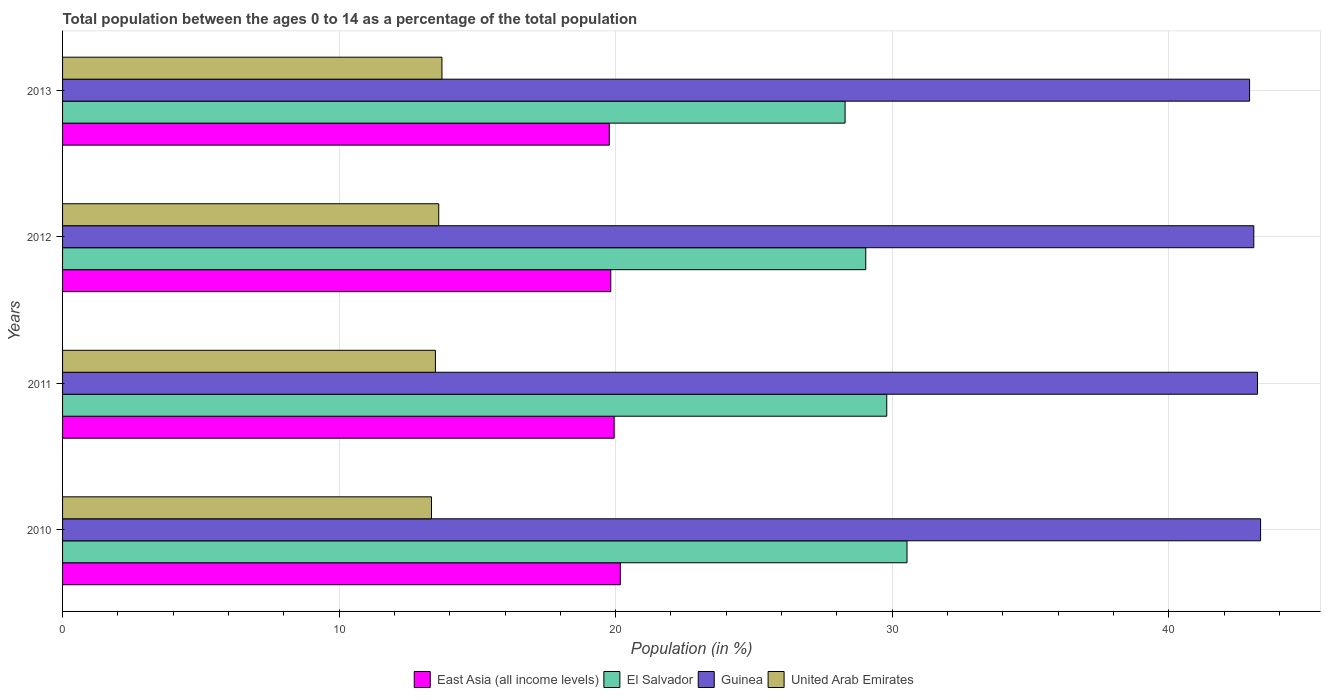Are the number of bars on each tick of the Y-axis equal?
Offer a terse response. Yes. What is the label of the 2nd group of bars from the top?
Give a very brief answer. 2012. In how many cases, is the number of bars for a given year not equal to the number of legend labels?
Offer a very short reply. 0. What is the percentage of the population ages 0 to 14 in El Salvador in 2011?
Offer a very short reply. 29.8. Across all years, what is the maximum percentage of the population ages 0 to 14 in United Arab Emirates?
Make the answer very short. 13.72. Across all years, what is the minimum percentage of the population ages 0 to 14 in El Salvador?
Provide a succinct answer. 28.3. In which year was the percentage of the population ages 0 to 14 in East Asia (all income levels) maximum?
Give a very brief answer. 2010. In which year was the percentage of the population ages 0 to 14 in East Asia (all income levels) minimum?
Your answer should be compact. 2013. What is the total percentage of the population ages 0 to 14 in East Asia (all income levels) in the graph?
Provide a short and direct response. 79.7. What is the difference between the percentage of the population ages 0 to 14 in East Asia (all income levels) in 2010 and that in 2011?
Keep it short and to the point. 0.22. What is the difference between the percentage of the population ages 0 to 14 in United Arab Emirates in 2010 and the percentage of the population ages 0 to 14 in Guinea in 2013?
Make the answer very short. -29.58. What is the average percentage of the population ages 0 to 14 in El Salvador per year?
Keep it short and to the point. 29.42. In the year 2010, what is the difference between the percentage of the population ages 0 to 14 in United Arab Emirates and percentage of the population ages 0 to 14 in East Asia (all income levels)?
Offer a terse response. -6.83. In how many years, is the percentage of the population ages 0 to 14 in United Arab Emirates greater than 36 ?
Offer a terse response. 0. What is the ratio of the percentage of the population ages 0 to 14 in Guinea in 2010 to that in 2011?
Give a very brief answer. 1. Is the difference between the percentage of the population ages 0 to 14 in United Arab Emirates in 2012 and 2013 greater than the difference between the percentage of the population ages 0 to 14 in East Asia (all income levels) in 2012 and 2013?
Provide a succinct answer. No. What is the difference between the highest and the second highest percentage of the population ages 0 to 14 in Guinea?
Your answer should be compact. 0.11. What is the difference between the highest and the lowest percentage of the population ages 0 to 14 in East Asia (all income levels)?
Your answer should be compact. 0.4. In how many years, is the percentage of the population ages 0 to 14 in East Asia (all income levels) greater than the average percentage of the population ages 0 to 14 in East Asia (all income levels) taken over all years?
Your answer should be very brief. 2. What does the 4th bar from the top in 2013 represents?
Offer a very short reply. East Asia (all income levels). What does the 3rd bar from the bottom in 2013 represents?
Ensure brevity in your answer.  Guinea. How many years are there in the graph?
Provide a short and direct response. 4. Are the values on the major ticks of X-axis written in scientific E-notation?
Offer a very short reply. No. Does the graph contain grids?
Offer a very short reply. Yes. Where does the legend appear in the graph?
Your response must be concise. Bottom center. How are the legend labels stacked?
Your response must be concise. Horizontal. What is the title of the graph?
Ensure brevity in your answer.  Total population between the ages 0 to 14 as a percentage of the total population. What is the Population (in %) in East Asia (all income levels) in 2010?
Your answer should be compact. 20.17. What is the Population (in %) in El Salvador in 2010?
Your answer should be very brief. 30.53. What is the Population (in %) in Guinea in 2010?
Offer a very short reply. 43.32. What is the Population (in %) in United Arab Emirates in 2010?
Provide a succinct answer. 13.34. What is the Population (in %) in East Asia (all income levels) in 2011?
Provide a succinct answer. 19.95. What is the Population (in %) of El Salvador in 2011?
Make the answer very short. 29.8. What is the Population (in %) of Guinea in 2011?
Provide a short and direct response. 43.21. What is the Population (in %) in United Arab Emirates in 2011?
Keep it short and to the point. 13.48. What is the Population (in %) of East Asia (all income levels) in 2012?
Provide a short and direct response. 19.82. What is the Population (in %) of El Salvador in 2012?
Give a very brief answer. 29.04. What is the Population (in %) of Guinea in 2012?
Provide a short and direct response. 43.07. What is the Population (in %) of United Arab Emirates in 2012?
Ensure brevity in your answer.  13.6. What is the Population (in %) of East Asia (all income levels) in 2013?
Offer a terse response. 19.77. What is the Population (in %) in El Salvador in 2013?
Make the answer very short. 28.3. What is the Population (in %) in Guinea in 2013?
Your response must be concise. 42.92. What is the Population (in %) in United Arab Emirates in 2013?
Your response must be concise. 13.72. Across all years, what is the maximum Population (in %) of East Asia (all income levels)?
Give a very brief answer. 20.17. Across all years, what is the maximum Population (in %) of El Salvador?
Keep it short and to the point. 30.53. Across all years, what is the maximum Population (in %) of Guinea?
Offer a terse response. 43.32. Across all years, what is the maximum Population (in %) in United Arab Emirates?
Ensure brevity in your answer.  13.72. Across all years, what is the minimum Population (in %) of East Asia (all income levels)?
Provide a succinct answer. 19.77. Across all years, what is the minimum Population (in %) in El Salvador?
Offer a terse response. 28.3. Across all years, what is the minimum Population (in %) of Guinea?
Offer a terse response. 42.92. Across all years, what is the minimum Population (in %) of United Arab Emirates?
Ensure brevity in your answer.  13.34. What is the total Population (in %) of East Asia (all income levels) in the graph?
Ensure brevity in your answer.  79.7. What is the total Population (in %) in El Salvador in the graph?
Make the answer very short. 117.67. What is the total Population (in %) of Guinea in the graph?
Ensure brevity in your answer.  172.52. What is the total Population (in %) of United Arab Emirates in the graph?
Offer a very short reply. 54.14. What is the difference between the Population (in %) in East Asia (all income levels) in 2010 and that in 2011?
Your answer should be very brief. 0.22. What is the difference between the Population (in %) in El Salvador in 2010 and that in 2011?
Your response must be concise. 0.73. What is the difference between the Population (in %) in Guinea in 2010 and that in 2011?
Your answer should be compact. 0.11. What is the difference between the Population (in %) in United Arab Emirates in 2010 and that in 2011?
Offer a terse response. -0.14. What is the difference between the Population (in %) in East Asia (all income levels) in 2010 and that in 2012?
Provide a short and direct response. 0.35. What is the difference between the Population (in %) of El Salvador in 2010 and that in 2012?
Make the answer very short. 1.49. What is the difference between the Population (in %) of Guinea in 2010 and that in 2012?
Offer a very short reply. 0.24. What is the difference between the Population (in %) of United Arab Emirates in 2010 and that in 2012?
Keep it short and to the point. -0.26. What is the difference between the Population (in %) of East Asia (all income levels) in 2010 and that in 2013?
Make the answer very short. 0.4. What is the difference between the Population (in %) of El Salvador in 2010 and that in 2013?
Your answer should be very brief. 2.24. What is the difference between the Population (in %) in Guinea in 2010 and that in 2013?
Your answer should be compact. 0.4. What is the difference between the Population (in %) of United Arab Emirates in 2010 and that in 2013?
Ensure brevity in your answer.  -0.38. What is the difference between the Population (in %) in East Asia (all income levels) in 2011 and that in 2012?
Offer a terse response. 0.12. What is the difference between the Population (in %) of El Salvador in 2011 and that in 2012?
Your response must be concise. 0.76. What is the difference between the Population (in %) of Guinea in 2011 and that in 2012?
Your response must be concise. 0.13. What is the difference between the Population (in %) of United Arab Emirates in 2011 and that in 2012?
Give a very brief answer. -0.12. What is the difference between the Population (in %) in East Asia (all income levels) in 2011 and that in 2013?
Offer a very short reply. 0.18. What is the difference between the Population (in %) in El Salvador in 2011 and that in 2013?
Provide a succinct answer. 1.51. What is the difference between the Population (in %) of Guinea in 2011 and that in 2013?
Provide a succinct answer. 0.29. What is the difference between the Population (in %) of United Arab Emirates in 2011 and that in 2013?
Give a very brief answer. -0.24. What is the difference between the Population (in %) of East Asia (all income levels) in 2012 and that in 2013?
Your answer should be compact. 0.05. What is the difference between the Population (in %) in El Salvador in 2012 and that in 2013?
Make the answer very short. 0.75. What is the difference between the Population (in %) of Guinea in 2012 and that in 2013?
Keep it short and to the point. 0.15. What is the difference between the Population (in %) of United Arab Emirates in 2012 and that in 2013?
Your answer should be very brief. -0.12. What is the difference between the Population (in %) in East Asia (all income levels) in 2010 and the Population (in %) in El Salvador in 2011?
Give a very brief answer. -9.63. What is the difference between the Population (in %) in East Asia (all income levels) in 2010 and the Population (in %) in Guinea in 2011?
Offer a very short reply. -23.04. What is the difference between the Population (in %) of East Asia (all income levels) in 2010 and the Population (in %) of United Arab Emirates in 2011?
Keep it short and to the point. 6.69. What is the difference between the Population (in %) of El Salvador in 2010 and the Population (in %) of Guinea in 2011?
Give a very brief answer. -12.67. What is the difference between the Population (in %) in El Salvador in 2010 and the Population (in %) in United Arab Emirates in 2011?
Offer a very short reply. 17.05. What is the difference between the Population (in %) of Guinea in 2010 and the Population (in %) of United Arab Emirates in 2011?
Provide a succinct answer. 29.84. What is the difference between the Population (in %) of East Asia (all income levels) in 2010 and the Population (in %) of El Salvador in 2012?
Offer a terse response. -8.87. What is the difference between the Population (in %) in East Asia (all income levels) in 2010 and the Population (in %) in Guinea in 2012?
Your answer should be very brief. -22.91. What is the difference between the Population (in %) of East Asia (all income levels) in 2010 and the Population (in %) of United Arab Emirates in 2012?
Offer a very short reply. 6.57. What is the difference between the Population (in %) in El Salvador in 2010 and the Population (in %) in Guinea in 2012?
Give a very brief answer. -12.54. What is the difference between the Population (in %) of El Salvador in 2010 and the Population (in %) of United Arab Emirates in 2012?
Keep it short and to the point. 16.93. What is the difference between the Population (in %) of Guinea in 2010 and the Population (in %) of United Arab Emirates in 2012?
Your response must be concise. 29.72. What is the difference between the Population (in %) of East Asia (all income levels) in 2010 and the Population (in %) of El Salvador in 2013?
Make the answer very short. -8.13. What is the difference between the Population (in %) of East Asia (all income levels) in 2010 and the Population (in %) of Guinea in 2013?
Your answer should be very brief. -22.75. What is the difference between the Population (in %) of East Asia (all income levels) in 2010 and the Population (in %) of United Arab Emirates in 2013?
Provide a succinct answer. 6.45. What is the difference between the Population (in %) of El Salvador in 2010 and the Population (in %) of Guinea in 2013?
Offer a terse response. -12.39. What is the difference between the Population (in %) in El Salvador in 2010 and the Population (in %) in United Arab Emirates in 2013?
Provide a short and direct response. 16.82. What is the difference between the Population (in %) of Guinea in 2010 and the Population (in %) of United Arab Emirates in 2013?
Ensure brevity in your answer.  29.6. What is the difference between the Population (in %) of East Asia (all income levels) in 2011 and the Population (in %) of El Salvador in 2012?
Your response must be concise. -9.1. What is the difference between the Population (in %) in East Asia (all income levels) in 2011 and the Population (in %) in Guinea in 2012?
Offer a terse response. -23.13. What is the difference between the Population (in %) of East Asia (all income levels) in 2011 and the Population (in %) of United Arab Emirates in 2012?
Ensure brevity in your answer.  6.34. What is the difference between the Population (in %) of El Salvador in 2011 and the Population (in %) of Guinea in 2012?
Provide a succinct answer. -13.27. What is the difference between the Population (in %) of El Salvador in 2011 and the Population (in %) of United Arab Emirates in 2012?
Give a very brief answer. 16.2. What is the difference between the Population (in %) of Guinea in 2011 and the Population (in %) of United Arab Emirates in 2012?
Your response must be concise. 29.6. What is the difference between the Population (in %) of East Asia (all income levels) in 2011 and the Population (in %) of El Salvador in 2013?
Provide a succinct answer. -8.35. What is the difference between the Population (in %) in East Asia (all income levels) in 2011 and the Population (in %) in Guinea in 2013?
Your answer should be compact. -22.98. What is the difference between the Population (in %) of East Asia (all income levels) in 2011 and the Population (in %) of United Arab Emirates in 2013?
Your answer should be compact. 6.23. What is the difference between the Population (in %) of El Salvador in 2011 and the Population (in %) of Guinea in 2013?
Make the answer very short. -13.12. What is the difference between the Population (in %) in El Salvador in 2011 and the Population (in %) in United Arab Emirates in 2013?
Provide a short and direct response. 16.08. What is the difference between the Population (in %) of Guinea in 2011 and the Population (in %) of United Arab Emirates in 2013?
Provide a short and direct response. 29.49. What is the difference between the Population (in %) in East Asia (all income levels) in 2012 and the Population (in %) in El Salvador in 2013?
Your response must be concise. -8.47. What is the difference between the Population (in %) in East Asia (all income levels) in 2012 and the Population (in %) in Guinea in 2013?
Make the answer very short. -23.1. What is the difference between the Population (in %) in East Asia (all income levels) in 2012 and the Population (in %) in United Arab Emirates in 2013?
Your answer should be compact. 6.1. What is the difference between the Population (in %) in El Salvador in 2012 and the Population (in %) in Guinea in 2013?
Provide a succinct answer. -13.88. What is the difference between the Population (in %) of El Salvador in 2012 and the Population (in %) of United Arab Emirates in 2013?
Give a very brief answer. 15.32. What is the difference between the Population (in %) of Guinea in 2012 and the Population (in %) of United Arab Emirates in 2013?
Provide a short and direct response. 29.36. What is the average Population (in %) in East Asia (all income levels) per year?
Give a very brief answer. 19.93. What is the average Population (in %) of El Salvador per year?
Provide a short and direct response. 29.42. What is the average Population (in %) in Guinea per year?
Provide a short and direct response. 43.13. What is the average Population (in %) in United Arab Emirates per year?
Offer a terse response. 13.54. In the year 2010, what is the difference between the Population (in %) in East Asia (all income levels) and Population (in %) in El Salvador?
Keep it short and to the point. -10.37. In the year 2010, what is the difference between the Population (in %) in East Asia (all income levels) and Population (in %) in Guinea?
Give a very brief answer. -23.15. In the year 2010, what is the difference between the Population (in %) of East Asia (all income levels) and Population (in %) of United Arab Emirates?
Keep it short and to the point. 6.83. In the year 2010, what is the difference between the Population (in %) of El Salvador and Population (in %) of Guinea?
Offer a terse response. -12.78. In the year 2010, what is the difference between the Population (in %) of El Salvador and Population (in %) of United Arab Emirates?
Keep it short and to the point. 17.19. In the year 2010, what is the difference between the Population (in %) in Guinea and Population (in %) in United Arab Emirates?
Make the answer very short. 29.98. In the year 2011, what is the difference between the Population (in %) in East Asia (all income levels) and Population (in %) in El Salvador?
Provide a short and direct response. -9.86. In the year 2011, what is the difference between the Population (in %) of East Asia (all income levels) and Population (in %) of Guinea?
Your response must be concise. -23.26. In the year 2011, what is the difference between the Population (in %) of East Asia (all income levels) and Population (in %) of United Arab Emirates?
Offer a very short reply. 6.46. In the year 2011, what is the difference between the Population (in %) in El Salvador and Population (in %) in Guinea?
Ensure brevity in your answer.  -13.41. In the year 2011, what is the difference between the Population (in %) in El Salvador and Population (in %) in United Arab Emirates?
Your response must be concise. 16.32. In the year 2011, what is the difference between the Population (in %) in Guinea and Population (in %) in United Arab Emirates?
Your answer should be compact. 29.73. In the year 2012, what is the difference between the Population (in %) in East Asia (all income levels) and Population (in %) in El Salvador?
Your response must be concise. -9.22. In the year 2012, what is the difference between the Population (in %) in East Asia (all income levels) and Population (in %) in Guinea?
Your answer should be very brief. -23.25. In the year 2012, what is the difference between the Population (in %) in East Asia (all income levels) and Population (in %) in United Arab Emirates?
Provide a short and direct response. 6.22. In the year 2012, what is the difference between the Population (in %) in El Salvador and Population (in %) in Guinea?
Give a very brief answer. -14.03. In the year 2012, what is the difference between the Population (in %) in El Salvador and Population (in %) in United Arab Emirates?
Provide a succinct answer. 15.44. In the year 2012, what is the difference between the Population (in %) in Guinea and Population (in %) in United Arab Emirates?
Offer a terse response. 29.47. In the year 2013, what is the difference between the Population (in %) in East Asia (all income levels) and Population (in %) in El Salvador?
Ensure brevity in your answer.  -8.53. In the year 2013, what is the difference between the Population (in %) in East Asia (all income levels) and Population (in %) in Guinea?
Your response must be concise. -23.15. In the year 2013, what is the difference between the Population (in %) of East Asia (all income levels) and Population (in %) of United Arab Emirates?
Provide a short and direct response. 6.05. In the year 2013, what is the difference between the Population (in %) of El Salvador and Population (in %) of Guinea?
Offer a terse response. -14.63. In the year 2013, what is the difference between the Population (in %) of El Salvador and Population (in %) of United Arab Emirates?
Offer a very short reply. 14.58. In the year 2013, what is the difference between the Population (in %) of Guinea and Population (in %) of United Arab Emirates?
Your answer should be very brief. 29.2. What is the ratio of the Population (in %) of East Asia (all income levels) in 2010 to that in 2011?
Your answer should be very brief. 1.01. What is the ratio of the Population (in %) in El Salvador in 2010 to that in 2011?
Provide a succinct answer. 1.02. What is the ratio of the Population (in %) of Guinea in 2010 to that in 2011?
Your response must be concise. 1. What is the ratio of the Population (in %) of East Asia (all income levels) in 2010 to that in 2012?
Your answer should be very brief. 1.02. What is the ratio of the Population (in %) in El Salvador in 2010 to that in 2012?
Your response must be concise. 1.05. What is the ratio of the Population (in %) in Guinea in 2010 to that in 2012?
Ensure brevity in your answer.  1.01. What is the ratio of the Population (in %) in United Arab Emirates in 2010 to that in 2012?
Keep it short and to the point. 0.98. What is the ratio of the Population (in %) of East Asia (all income levels) in 2010 to that in 2013?
Provide a succinct answer. 1.02. What is the ratio of the Population (in %) of El Salvador in 2010 to that in 2013?
Keep it short and to the point. 1.08. What is the ratio of the Population (in %) in Guinea in 2010 to that in 2013?
Offer a very short reply. 1.01. What is the ratio of the Population (in %) of United Arab Emirates in 2010 to that in 2013?
Give a very brief answer. 0.97. What is the ratio of the Population (in %) of East Asia (all income levels) in 2011 to that in 2012?
Ensure brevity in your answer.  1.01. What is the ratio of the Population (in %) of El Salvador in 2011 to that in 2012?
Keep it short and to the point. 1.03. What is the ratio of the Population (in %) of Guinea in 2011 to that in 2012?
Provide a succinct answer. 1. What is the ratio of the Population (in %) of East Asia (all income levels) in 2011 to that in 2013?
Give a very brief answer. 1.01. What is the ratio of the Population (in %) in El Salvador in 2011 to that in 2013?
Offer a terse response. 1.05. What is the ratio of the Population (in %) in United Arab Emirates in 2011 to that in 2013?
Your answer should be very brief. 0.98. What is the ratio of the Population (in %) of El Salvador in 2012 to that in 2013?
Give a very brief answer. 1.03. What is the difference between the highest and the second highest Population (in %) of East Asia (all income levels)?
Your answer should be very brief. 0.22. What is the difference between the highest and the second highest Population (in %) in El Salvador?
Keep it short and to the point. 0.73. What is the difference between the highest and the second highest Population (in %) in Guinea?
Make the answer very short. 0.11. What is the difference between the highest and the second highest Population (in %) of United Arab Emirates?
Your response must be concise. 0.12. What is the difference between the highest and the lowest Population (in %) in East Asia (all income levels)?
Keep it short and to the point. 0.4. What is the difference between the highest and the lowest Population (in %) of El Salvador?
Offer a terse response. 2.24. What is the difference between the highest and the lowest Population (in %) of Guinea?
Give a very brief answer. 0.4. What is the difference between the highest and the lowest Population (in %) of United Arab Emirates?
Offer a terse response. 0.38. 